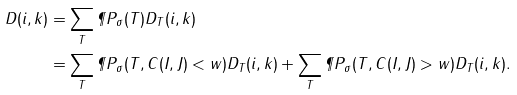Convert formula to latex. <formula><loc_0><loc_0><loc_500><loc_500>D ( i , k ) & = \sum _ { T } \P P _ { \sigma } ( T ) D _ { T } ( i , k ) \\ & = \sum _ { T } \P P _ { \sigma } ( T , C ( I , J ) < w ) D _ { T } ( i , k ) + \sum _ { T } \P P _ { \sigma } ( T , C ( I , J ) > w ) D _ { T } ( i , k ) .</formula> 